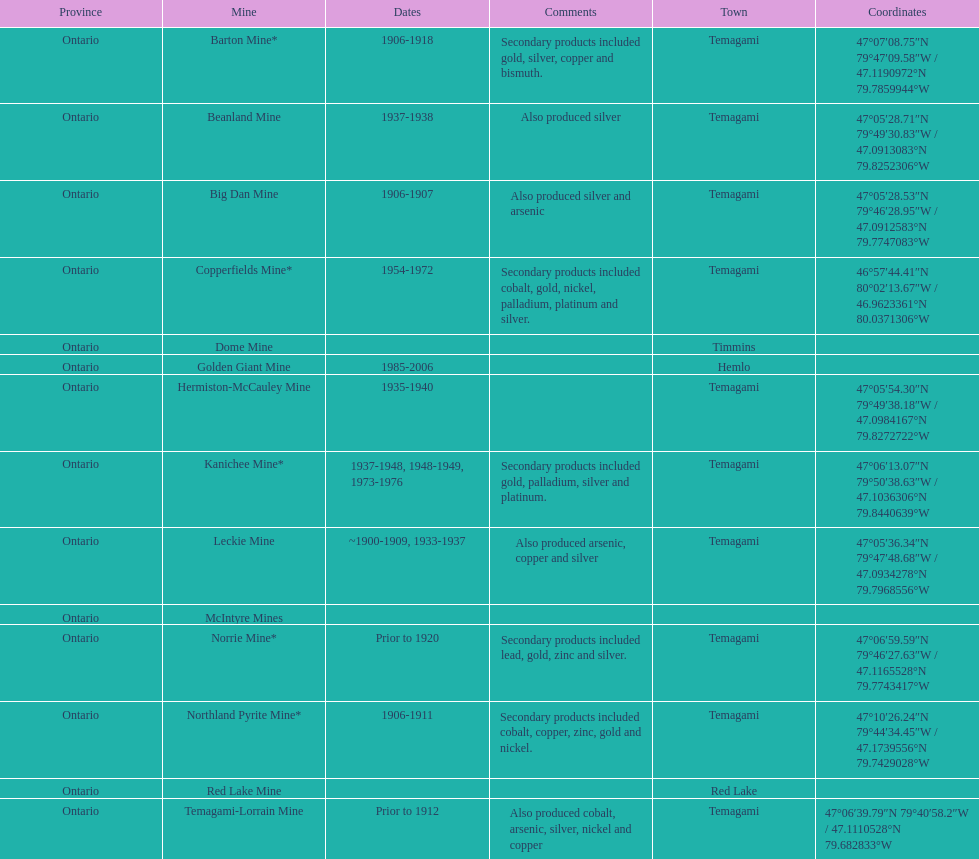How many times is temagami listedon the list? 10. 